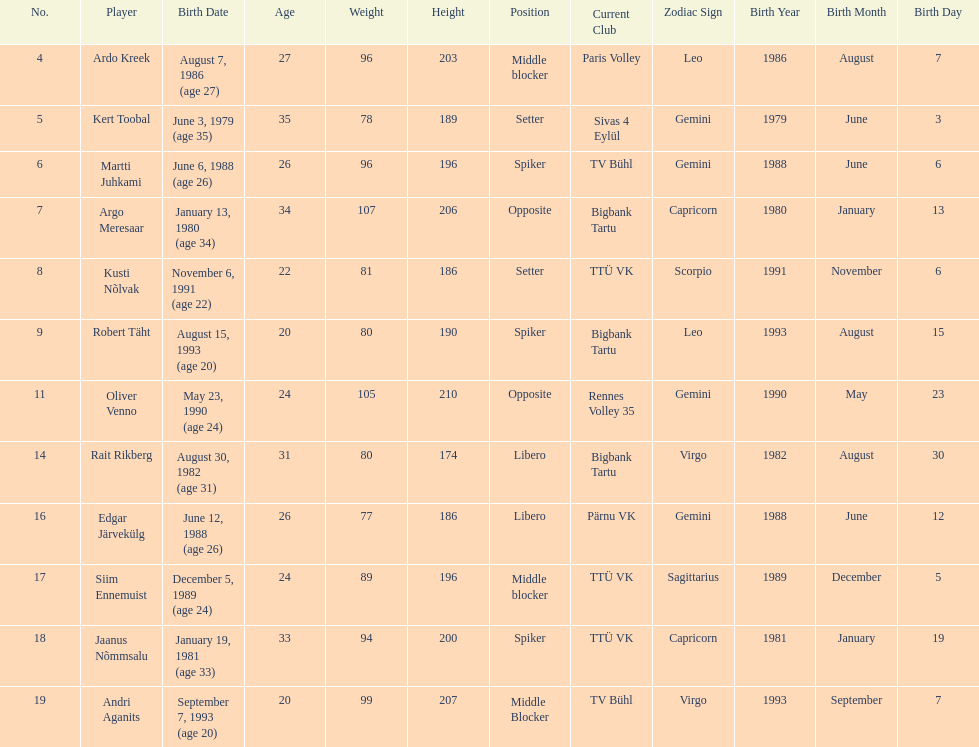Who stands taller than andri agantis among players? Oliver Venno. 